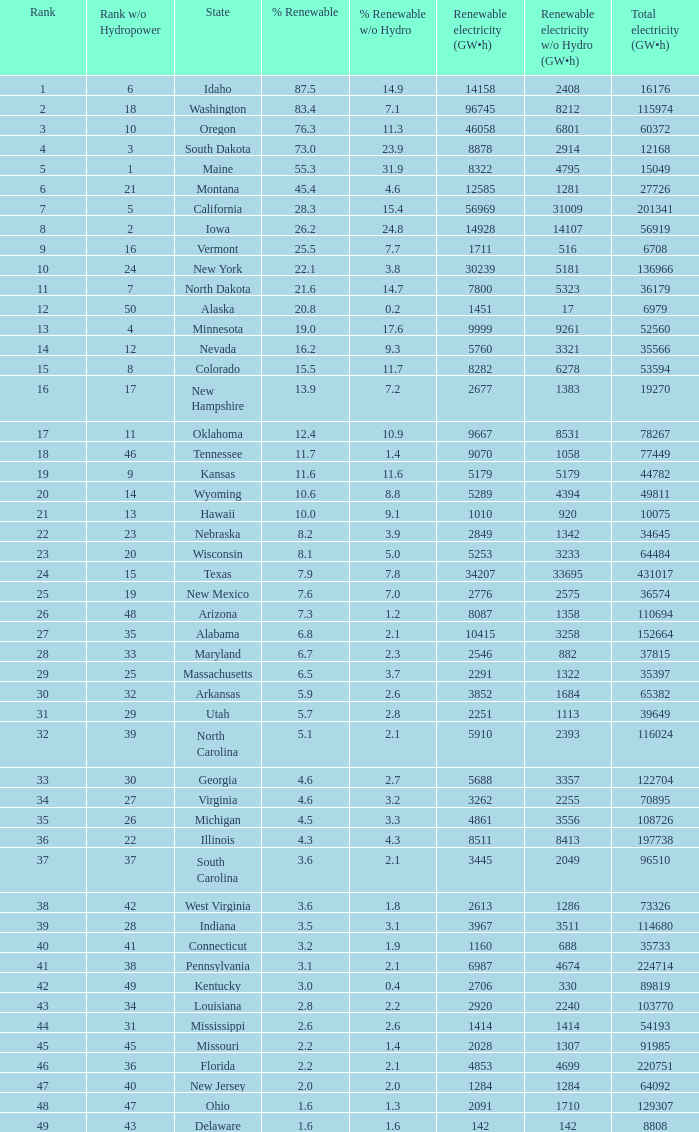What is the amount of renewable electricity without hydrogen power when the percentage of renewable energy is 83.4? 8212.0. 